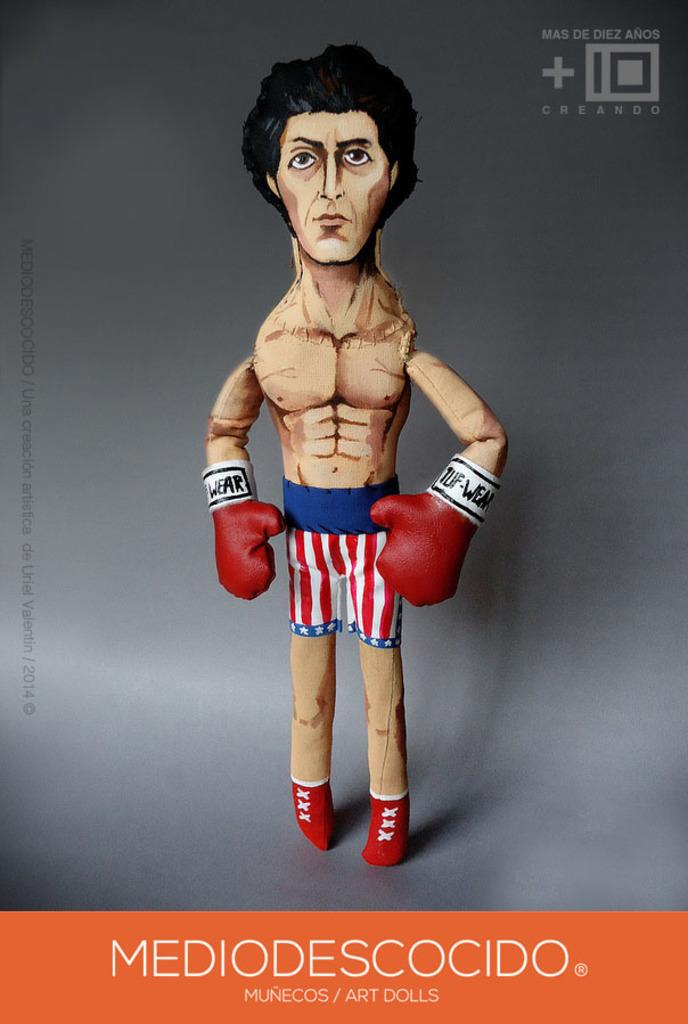<image>
Present a compact description of the photo's key features. Poster of a boxer with MEDIODESCOCIDO in white letters at the bottom. 